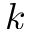Convert formula to latex. <formula><loc_0><loc_0><loc_500><loc_500>k</formula> 